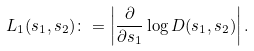Convert formula to latex. <formula><loc_0><loc_0><loc_500><loc_500>L _ { 1 } ( s _ { 1 } , s _ { 2 } ) \colon = \left | \frac { \partial } { \partial s _ { 1 } } \log D ( s _ { 1 } , s _ { 2 } ) \right | .</formula> 